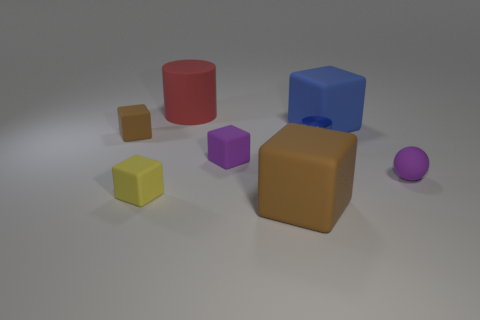Subtract all yellow blocks. How many blocks are left? 4 Subtract all purple cubes. How many cubes are left? 4 Subtract all red cubes. Subtract all cyan balls. How many cubes are left? 5 Add 1 small blue spheres. How many objects exist? 9 Subtract all spheres. How many objects are left? 7 Add 4 large matte objects. How many large matte objects are left? 7 Add 8 large rubber blocks. How many large rubber blocks exist? 10 Subtract 1 purple cubes. How many objects are left? 7 Subtract all small brown cubes. Subtract all purple metal spheres. How many objects are left? 7 